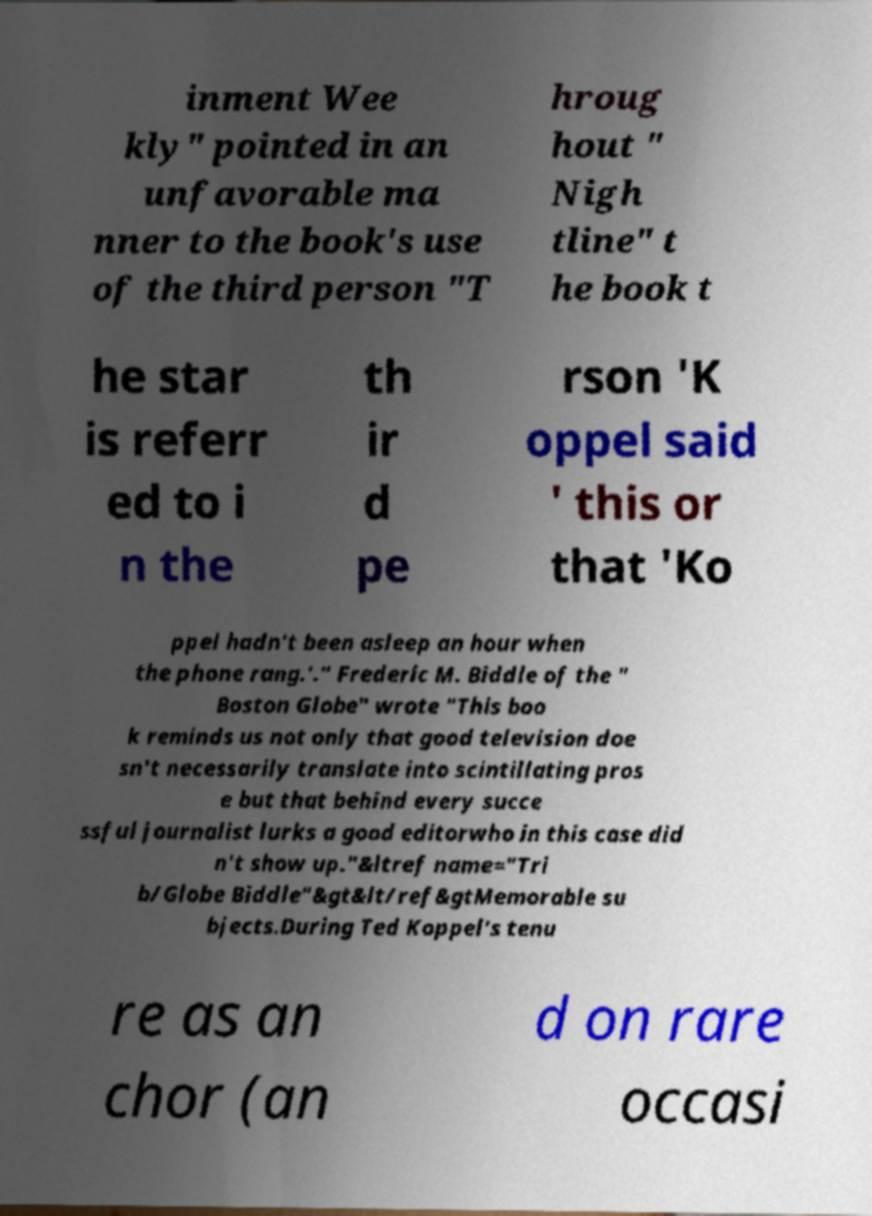Please read and relay the text visible in this image. What does it say? inment Wee kly" pointed in an unfavorable ma nner to the book's use of the third person "T hroug hout " Nigh tline" t he book t he star is referr ed to i n the th ir d pe rson 'K oppel said ' this or that 'Ko ppel hadn’t been asleep an hour when the phone rang.'." Frederic M. Biddle of the " Boston Globe" wrote "This boo k reminds us not only that good television doe sn't necessarily translate into scintillating pros e but that behind every succe ssful journalist lurks a good editorwho in this case did n't show up."&ltref name="Tri b/Globe Biddle"&gt&lt/ref&gtMemorable su bjects.During Ted Koppel's tenu re as an chor (an d on rare occasi 